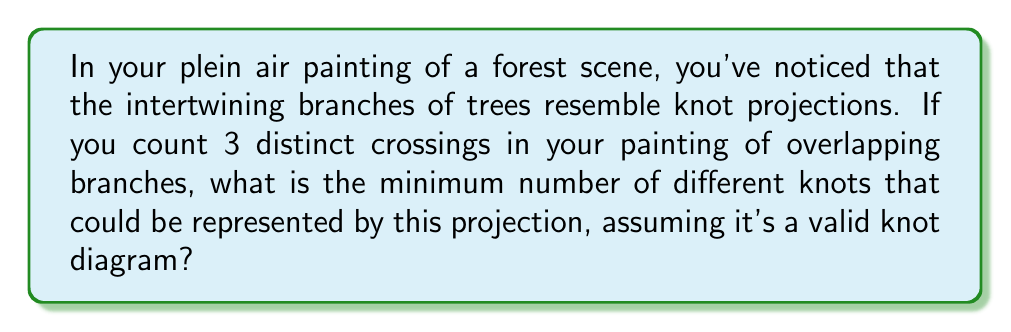Show me your answer to this math problem. Let's approach this step-by-step:

1) In knot theory, a knot projection with 3 crossings could represent several different knots:

   a) The unknot (trivial knot)
   b) The trefoil knot

2) The unknot can have any number of crossings in its projection, including 3, due to possible twists or kinks that can be undone without cutting the knot.

3) The trefoil knot is the simplest non-trivial knot and has a minimal crossing number of 3.

4) Any knot with a minimal crossing number greater than 3 (like the figure-eight knot with 4 crossings) cannot be represented by a 3-crossing projection.

5) Therefore, the 3-crossing projection in your painting could represent either the unknot or the trefoil knot.

6) Mathematically, we can express the number of possible knots as:

   $$\text{Number of knots} = |\{\text{unknot}, \text{trefoil}\}| = 2$$

7) This aligns with the concept in knot theory that the same knot can have many different projections, and different knots can have projections with the same number of crossings.
Answer: 2 